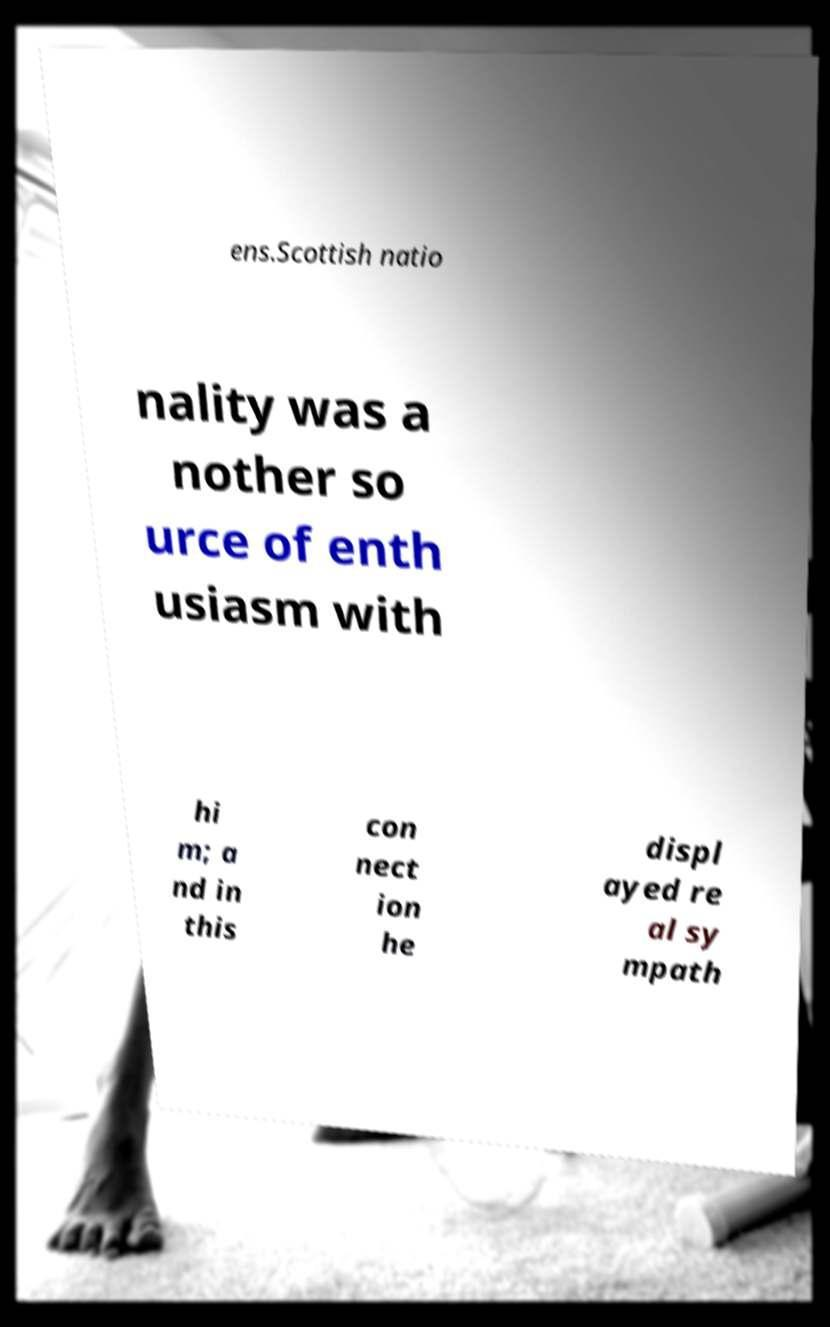What messages or text are displayed in this image? I need them in a readable, typed format. ens.Scottish natio nality was a nother so urce of enth usiasm with hi m; a nd in this con nect ion he displ ayed re al sy mpath 